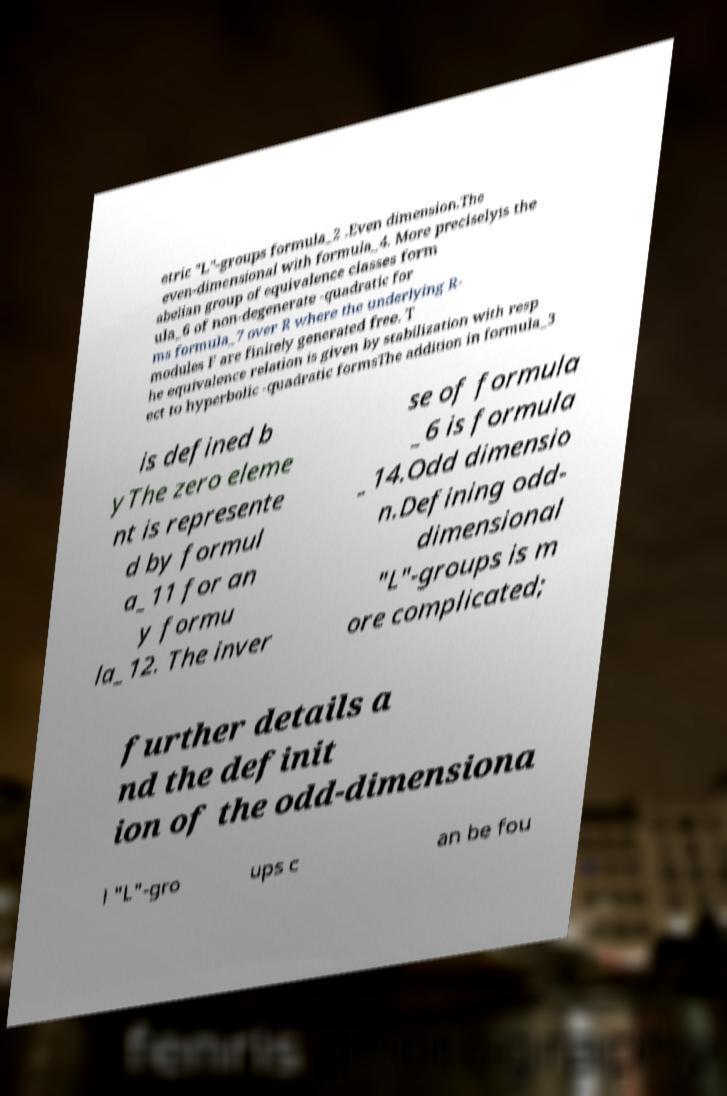For documentation purposes, I need the text within this image transcribed. Could you provide that? etric "L"-groups formula_2 .Even dimension.The even-dimensional with formula_4. More preciselyis the abelian group of equivalence classes form ula_6 of non-degenerate -quadratic for ms formula_7 over R where the underlying R- modules F are finitely generated free. T he equivalence relation is given by stabilization with resp ect to hyperbolic -quadratic formsThe addition in formula_3 is defined b yThe zero eleme nt is represente d by formul a_11 for an y formu la_12. The inver se of formula _6 is formula _14.Odd dimensio n.Defining odd- dimensional "L"-groups is m ore complicated; further details a nd the definit ion of the odd-dimensiona l "L"-gro ups c an be fou 